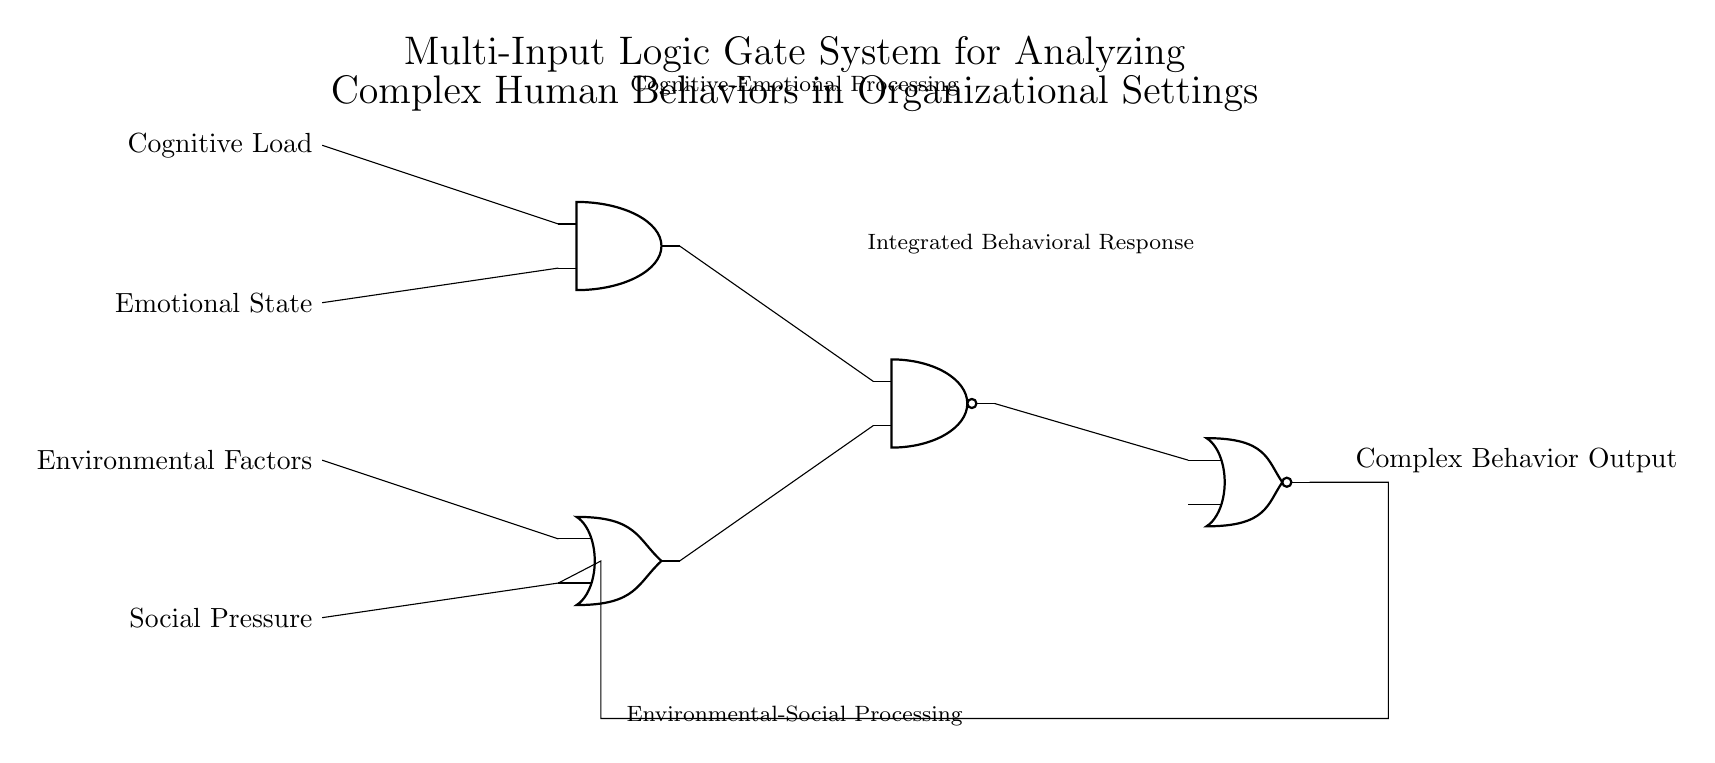What types of inputs are used in this circuit? The circuit diagram shows four inputs: Cognitive Load, Emotional State, Environmental Factors, and Social Pressure, which are connected to different logic gates.
Answer: Cognitive Load, Emotional State, Environmental Factors, Social Pressure What type of output does this circuit generate? The output of the circuit is labeled as Complex Behavior Output, indicating that it produces a single output based on the processed inputs.
Answer: Complex Behavior Output How many logic gates are present in this circuit? There are four distinct logic gates visible in the circuit: one AND gate, one OR gate, one NAND gate, and one NOR gate, each serving a different function in processing the inputs.
Answer: Four Which logic gate receives outputs from both the AND and OR gates? The NAND gate takes its inputs from the outputs of the AND gate and the OR gate, combining signals from both to produce its result.
Answer: NAND gate What is the purpose of the feedback loop in this circuit? The feedback loop connects the output of the NOR gate back to the OR gate, allowing the circuit to iteratively refine its output based on previous results, influencing the subsequent behavior.
Answer: Iterative refinement Which two types of processing are indicated in the circuit diagram? The labels in the diagram indicate two types of processing: Cognitive-Emotional Processing and Environmental-Social Processing, representing the dual nature of the input handling.
Answer: Cognitive-Emotional Processing, Environmental-Social Processing What component comes after the AND and OR gates in the signal flow? The component that follows both the AND and OR gates is the NAND gate, which is fed by their outputs for further processing before reaching the final output.
Answer: NAND gate 